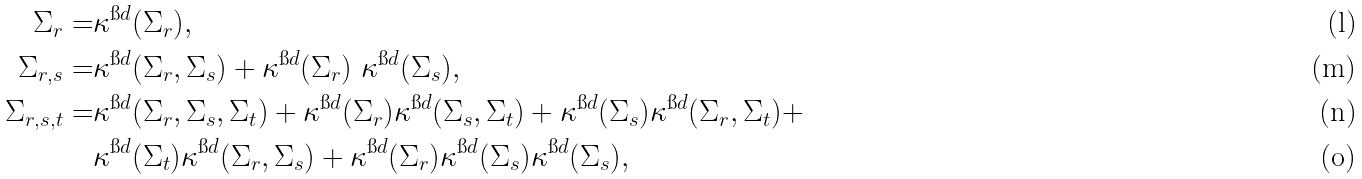<formula> <loc_0><loc_0><loc_500><loc_500>\Sigma _ { r } = & \kappa ^ { \i d } ( \Sigma _ { r } ) , \\ \Sigma _ { r , s } = & \kappa ^ { \i d } ( \Sigma _ { r } , \Sigma _ { s } ) + \kappa ^ { \i d } ( \Sigma _ { r } ) \ \kappa ^ { \i d } ( \Sigma _ { s } ) , \\ \Sigma _ { r , s , t } = & \kappa ^ { \i d } ( \Sigma _ { r } , \Sigma _ { s } , \Sigma _ { t } ) + \kappa ^ { \i d } ( \Sigma _ { r } ) \kappa ^ { \i d } ( \Sigma _ { s } , \Sigma _ { t } ) + \kappa ^ { \i d } ( \Sigma _ { s } ) \kappa ^ { \i d } ( \Sigma _ { r } , \Sigma _ { t } ) + \\ & \kappa ^ { \i d } ( \Sigma _ { t } ) \kappa ^ { \i d } ( \Sigma _ { r } , \Sigma _ { s } ) + \kappa ^ { \i d } ( \Sigma _ { r } ) \kappa ^ { \i d } ( \Sigma _ { s } ) \kappa ^ { \i d } ( \Sigma _ { s } ) ,</formula> 